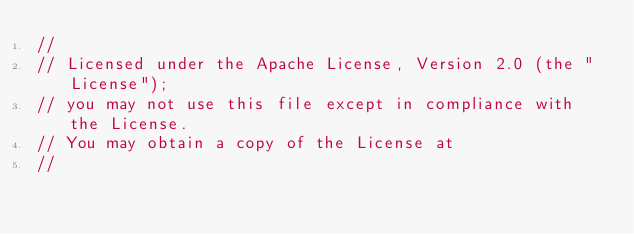Convert code to text. <code><loc_0><loc_0><loc_500><loc_500><_Go_>//
// Licensed under the Apache License, Version 2.0 (the "License");
// you may not use this file except in compliance with the License.
// You may obtain a copy of the License at
//</code> 